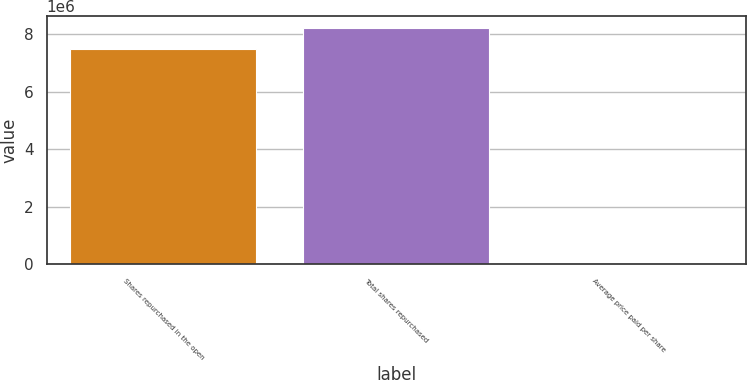Convert chart. <chart><loc_0><loc_0><loc_500><loc_500><bar_chart><fcel>Shares repurchased in the open<fcel>Total shares repurchased<fcel>Average price paid per share<nl><fcel>7.46723e+06<fcel>8.21394e+06<fcel>80.5<nl></chart> 